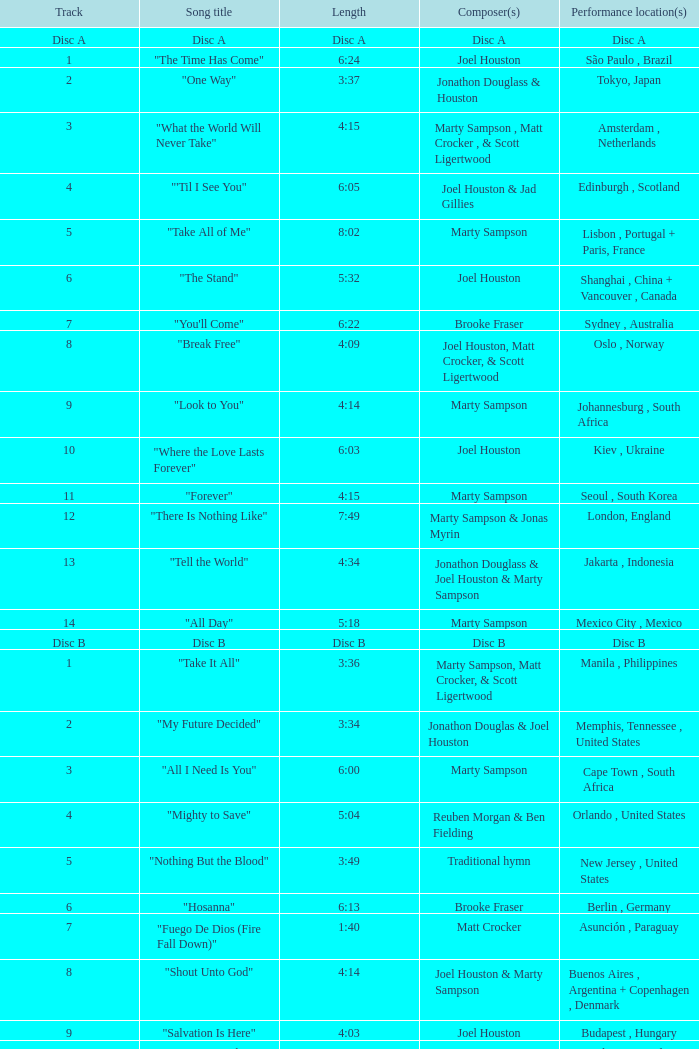What is the duration of track 16? 5:55. 